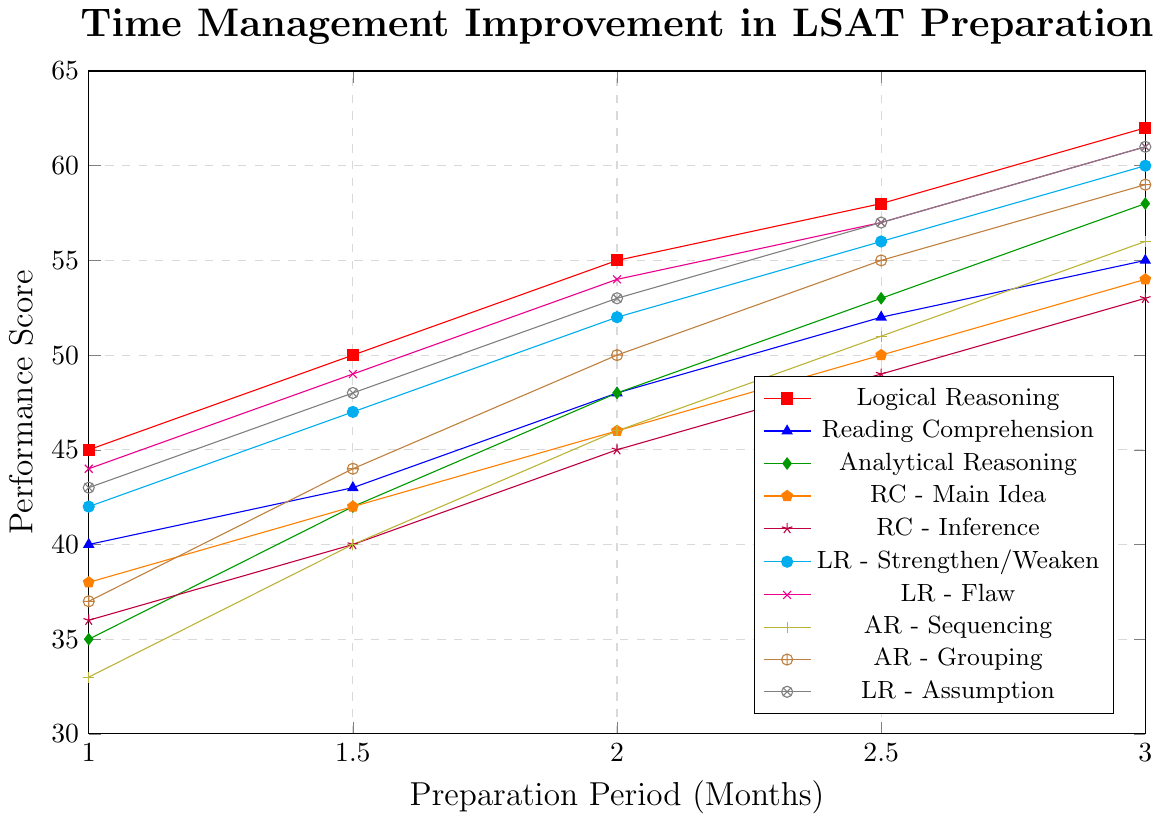What's the largest performance score improvement seen over the 3-month period? The largest performance score improvement is the highest difference between the score at Month 3 and Month 1. Analytical Reasoning shows an improvement of 58 - 35 = 23 points.
Answer: 23 Which question type had the highest score at the end of Month 1? At the end of Month 1, Logical Reasoning has the highest score with 45 points.
Answer: Logical Reasoning How much did the performance score for RC - Inference improve from Month 1.5 to Month 2.5? The improvement for RC - Inference from Month 1.5 to Month 2.5 is found by subtracting the Month 1.5 score from the Month 2.5 score, which is 49 - 40 = 9 points.
Answer: 9 Between LR - Flaw and LR - Assumption, which one saw a greater improvement from Month 1 to Month 3? Calculate the improvement for each: LR - Flaw improved by 61 - 44 = 17 points, and LR - Assumption improved by 61 - 43 = 18 points. LR - Assumption had a greater improvement.
Answer: LR - Assumption Which question type shows the most consistent improvement over the 3-month period? Logical Reasoning shows the most consistent improvement as it increases steadily over each half-month increment.
Answer: Logical Reasoning What is the average performance score for Reading Comprehension across all months? Calculate the average by summing all scores for Reading Comprehension and dividing by the number of scores: (40 + 43 + 48 + 52 + 55) / 5 = 47.6.
Answer: 47.6 Which question type had the lowest initial score and what was it? Analytical Reasoning had the lowest initial score with 35 points at Month 1.
Answer: Analytical Reasoning What is the difference in performance between Logical Reasoning and RC - Inference at Month 3? The difference is the performance score of Logical Reasoning minus the score of RC - Inference at Month 3, which is 62 - 53 = 9 points.
Answer: 9 What was the performance score for AR - Grouping in Month 2.5? By looking at the figure, AR - Grouping had a performance score of 55 in Month 2.5.
Answer: 55 